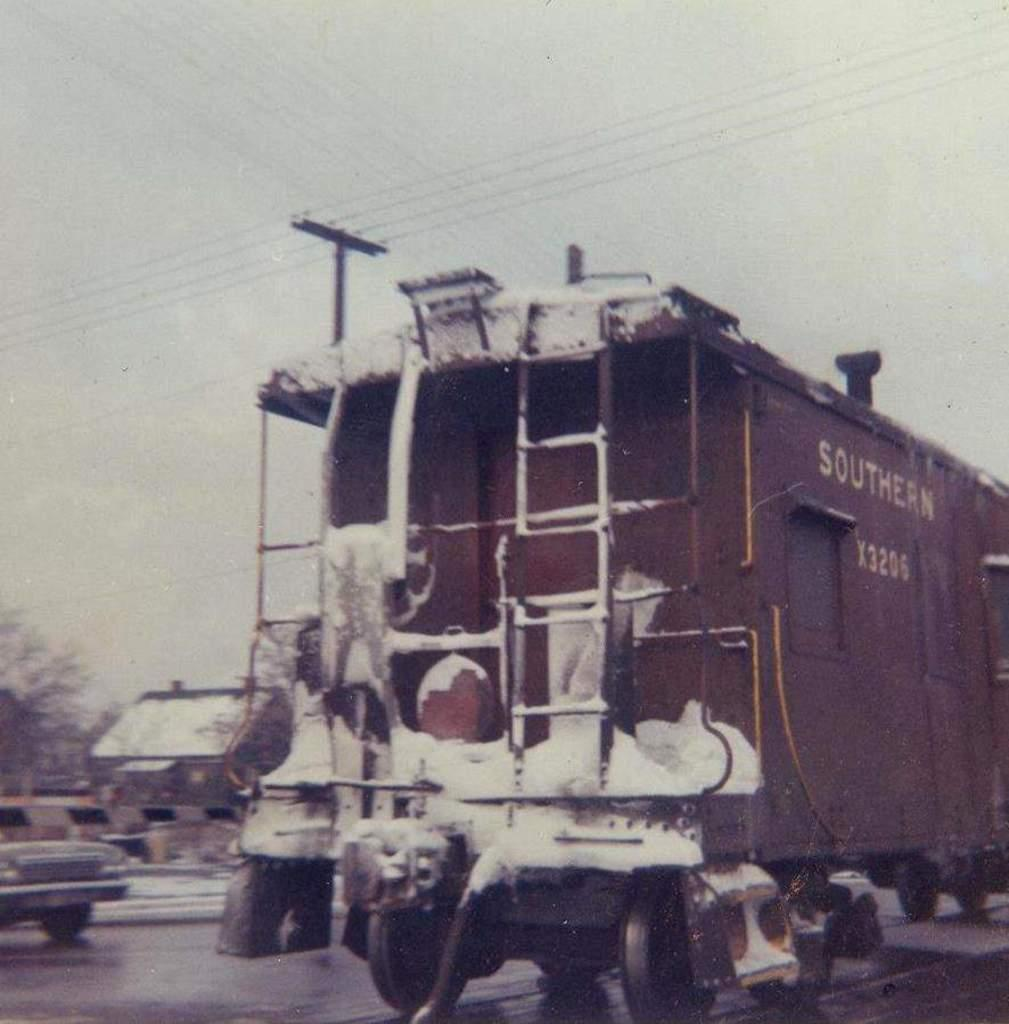What is the main subject in the center of the image? There is a train in the center of the image. What is covering the train in the image? The train has snow on it. What can be seen in the background of the image? There are houses, trees, and a car in the background of the image. What is visible at the top of the image? The sky is visible at the top of the image. What else can be seen in the image? There are wires in the image. What type of selection process is being conducted in the image? There is no selection process being conducted in the image; it features a snow-covered train and its surroundings. What religion is being practiced in the image? There is no indication of any religious practice in the image. 